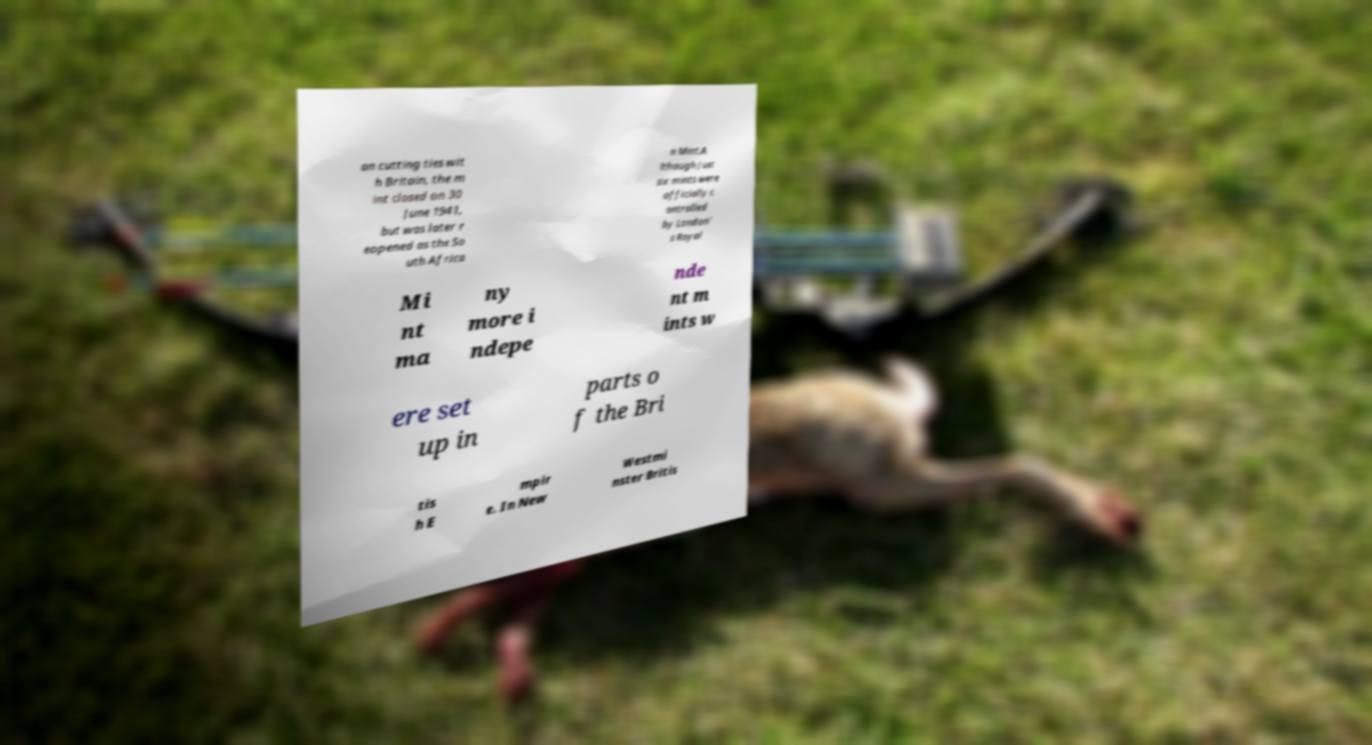There's text embedded in this image that I need extracted. Can you transcribe it verbatim? an cutting ties wit h Britain, the m int closed on 30 June 1941, but was later r eopened as the So uth Africa n Mint.A lthough just six mints were officially c ontrolled by London' s Royal Mi nt ma ny more i ndepe nde nt m ints w ere set up in parts o f the Bri tis h E mpir e. In New Westmi nster Britis 